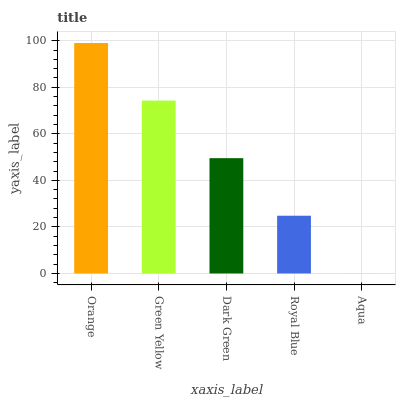Is Green Yellow the minimum?
Answer yes or no. No. Is Green Yellow the maximum?
Answer yes or no. No. Is Orange greater than Green Yellow?
Answer yes or no. Yes. Is Green Yellow less than Orange?
Answer yes or no. Yes. Is Green Yellow greater than Orange?
Answer yes or no. No. Is Orange less than Green Yellow?
Answer yes or no. No. Is Dark Green the high median?
Answer yes or no. Yes. Is Dark Green the low median?
Answer yes or no. Yes. Is Orange the high median?
Answer yes or no. No. Is Orange the low median?
Answer yes or no. No. 